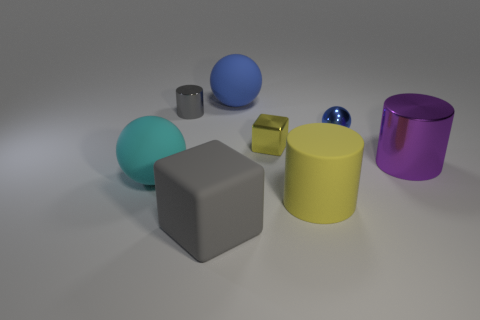Subtract all gray blocks. How many blue spheres are left? 2 Subtract all big rubber balls. How many balls are left? 1 Add 1 gray cylinders. How many objects exist? 9 Subtract all balls. How many objects are left? 5 Add 2 large purple metal things. How many large purple metal things are left? 3 Add 1 small gray metal things. How many small gray metal things exist? 2 Subtract 0 brown cylinders. How many objects are left? 8 Subtract all yellow cubes. Subtract all big gray blocks. How many objects are left? 6 